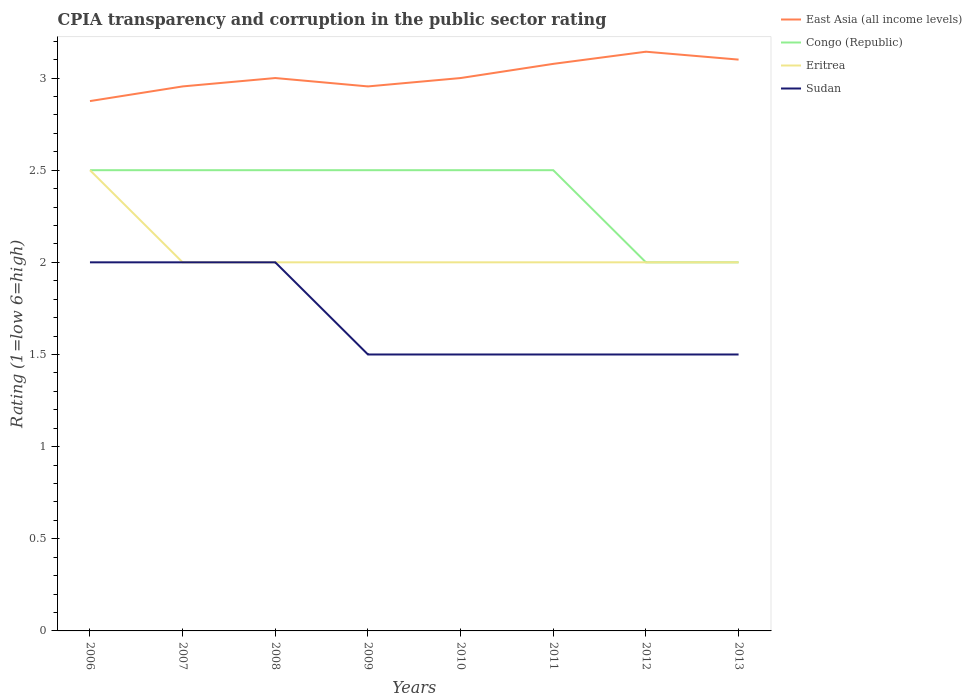Does the line corresponding to East Asia (all income levels) intersect with the line corresponding to Eritrea?
Your response must be concise. No. Across all years, what is the maximum CPIA rating in Congo (Republic)?
Make the answer very short. 2. What is the difference between the highest and the lowest CPIA rating in Eritrea?
Ensure brevity in your answer.  1. Is the CPIA rating in Eritrea strictly greater than the CPIA rating in Sudan over the years?
Your response must be concise. No. How many lines are there?
Your response must be concise. 4. How many years are there in the graph?
Offer a very short reply. 8. Are the values on the major ticks of Y-axis written in scientific E-notation?
Provide a succinct answer. No. Does the graph contain any zero values?
Ensure brevity in your answer.  No. Where does the legend appear in the graph?
Give a very brief answer. Top right. What is the title of the graph?
Offer a very short reply. CPIA transparency and corruption in the public sector rating. What is the label or title of the X-axis?
Provide a short and direct response. Years. What is the label or title of the Y-axis?
Your answer should be compact. Rating (1=low 6=high). What is the Rating (1=low 6=high) of East Asia (all income levels) in 2006?
Make the answer very short. 2.88. What is the Rating (1=low 6=high) of East Asia (all income levels) in 2007?
Provide a short and direct response. 2.95. What is the Rating (1=low 6=high) in Congo (Republic) in 2007?
Keep it short and to the point. 2.5. What is the Rating (1=low 6=high) in East Asia (all income levels) in 2008?
Provide a short and direct response. 3. What is the Rating (1=low 6=high) of East Asia (all income levels) in 2009?
Provide a short and direct response. 2.95. What is the Rating (1=low 6=high) of Congo (Republic) in 2009?
Your response must be concise. 2.5. What is the Rating (1=low 6=high) in Eritrea in 2009?
Make the answer very short. 2. What is the Rating (1=low 6=high) in Sudan in 2009?
Keep it short and to the point. 1.5. What is the Rating (1=low 6=high) of East Asia (all income levels) in 2010?
Ensure brevity in your answer.  3. What is the Rating (1=low 6=high) in East Asia (all income levels) in 2011?
Offer a very short reply. 3.08. What is the Rating (1=low 6=high) in Congo (Republic) in 2011?
Your answer should be very brief. 2.5. What is the Rating (1=low 6=high) in Eritrea in 2011?
Your answer should be very brief. 2. What is the Rating (1=low 6=high) in Sudan in 2011?
Provide a succinct answer. 1.5. What is the Rating (1=low 6=high) of East Asia (all income levels) in 2012?
Provide a short and direct response. 3.14. What is the Rating (1=low 6=high) of Sudan in 2012?
Offer a terse response. 1.5. What is the Rating (1=low 6=high) of East Asia (all income levels) in 2013?
Provide a short and direct response. 3.1. What is the Rating (1=low 6=high) of Eritrea in 2013?
Give a very brief answer. 2. What is the Rating (1=low 6=high) in Sudan in 2013?
Offer a very short reply. 1.5. Across all years, what is the maximum Rating (1=low 6=high) of East Asia (all income levels)?
Provide a short and direct response. 3.14. Across all years, what is the maximum Rating (1=low 6=high) of Congo (Republic)?
Make the answer very short. 2.5. Across all years, what is the maximum Rating (1=low 6=high) of Eritrea?
Give a very brief answer. 2.5. Across all years, what is the minimum Rating (1=low 6=high) in East Asia (all income levels)?
Make the answer very short. 2.88. Across all years, what is the minimum Rating (1=low 6=high) in Congo (Republic)?
Provide a succinct answer. 2. Across all years, what is the minimum Rating (1=low 6=high) of Eritrea?
Provide a short and direct response. 2. What is the total Rating (1=low 6=high) of East Asia (all income levels) in the graph?
Your response must be concise. 24.1. What is the difference between the Rating (1=low 6=high) of East Asia (all income levels) in 2006 and that in 2007?
Give a very brief answer. -0.08. What is the difference between the Rating (1=low 6=high) of Congo (Republic) in 2006 and that in 2007?
Keep it short and to the point. 0. What is the difference between the Rating (1=low 6=high) of Eritrea in 2006 and that in 2007?
Ensure brevity in your answer.  0.5. What is the difference between the Rating (1=low 6=high) of East Asia (all income levels) in 2006 and that in 2008?
Your answer should be very brief. -0.12. What is the difference between the Rating (1=low 6=high) in Eritrea in 2006 and that in 2008?
Give a very brief answer. 0.5. What is the difference between the Rating (1=low 6=high) of Sudan in 2006 and that in 2008?
Provide a short and direct response. 0. What is the difference between the Rating (1=low 6=high) in East Asia (all income levels) in 2006 and that in 2009?
Give a very brief answer. -0.08. What is the difference between the Rating (1=low 6=high) of Sudan in 2006 and that in 2009?
Keep it short and to the point. 0.5. What is the difference between the Rating (1=low 6=high) in East Asia (all income levels) in 2006 and that in 2010?
Give a very brief answer. -0.12. What is the difference between the Rating (1=low 6=high) in Congo (Republic) in 2006 and that in 2010?
Ensure brevity in your answer.  0. What is the difference between the Rating (1=low 6=high) of East Asia (all income levels) in 2006 and that in 2011?
Provide a short and direct response. -0.2. What is the difference between the Rating (1=low 6=high) of East Asia (all income levels) in 2006 and that in 2012?
Keep it short and to the point. -0.27. What is the difference between the Rating (1=low 6=high) in Eritrea in 2006 and that in 2012?
Provide a short and direct response. 0.5. What is the difference between the Rating (1=low 6=high) in Sudan in 2006 and that in 2012?
Give a very brief answer. 0.5. What is the difference between the Rating (1=low 6=high) of East Asia (all income levels) in 2006 and that in 2013?
Give a very brief answer. -0.23. What is the difference between the Rating (1=low 6=high) of East Asia (all income levels) in 2007 and that in 2008?
Ensure brevity in your answer.  -0.05. What is the difference between the Rating (1=low 6=high) of Sudan in 2007 and that in 2008?
Offer a very short reply. 0. What is the difference between the Rating (1=low 6=high) in East Asia (all income levels) in 2007 and that in 2009?
Keep it short and to the point. 0. What is the difference between the Rating (1=low 6=high) of Congo (Republic) in 2007 and that in 2009?
Your answer should be compact. 0. What is the difference between the Rating (1=low 6=high) in Sudan in 2007 and that in 2009?
Your response must be concise. 0.5. What is the difference between the Rating (1=low 6=high) of East Asia (all income levels) in 2007 and that in 2010?
Keep it short and to the point. -0.05. What is the difference between the Rating (1=low 6=high) in Congo (Republic) in 2007 and that in 2010?
Your answer should be very brief. 0. What is the difference between the Rating (1=low 6=high) in East Asia (all income levels) in 2007 and that in 2011?
Provide a succinct answer. -0.12. What is the difference between the Rating (1=low 6=high) of Congo (Republic) in 2007 and that in 2011?
Make the answer very short. 0. What is the difference between the Rating (1=low 6=high) in Sudan in 2007 and that in 2011?
Keep it short and to the point. 0.5. What is the difference between the Rating (1=low 6=high) in East Asia (all income levels) in 2007 and that in 2012?
Offer a terse response. -0.19. What is the difference between the Rating (1=low 6=high) in Congo (Republic) in 2007 and that in 2012?
Provide a short and direct response. 0.5. What is the difference between the Rating (1=low 6=high) in Eritrea in 2007 and that in 2012?
Keep it short and to the point. 0. What is the difference between the Rating (1=low 6=high) of East Asia (all income levels) in 2007 and that in 2013?
Make the answer very short. -0.15. What is the difference between the Rating (1=low 6=high) in Congo (Republic) in 2007 and that in 2013?
Provide a short and direct response. 0.5. What is the difference between the Rating (1=low 6=high) of Sudan in 2007 and that in 2013?
Provide a succinct answer. 0.5. What is the difference between the Rating (1=low 6=high) of East Asia (all income levels) in 2008 and that in 2009?
Your answer should be compact. 0.05. What is the difference between the Rating (1=low 6=high) in Sudan in 2008 and that in 2009?
Provide a succinct answer. 0.5. What is the difference between the Rating (1=low 6=high) of Congo (Republic) in 2008 and that in 2010?
Your response must be concise. 0. What is the difference between the Rating (1=low 6=high) in Eritrea in 2008 and that in 2010?
Provide a short and direct response. 0. What is the difference between the Rating (1=low 6=high) in Sudan in 2008 and that in 2010?
Keep it short and to the point. 0.5. What is the difference between the Rating (1=low 6=high) in East Asia (all income levels) in 2008 and that in 2011?
Your answer should be very brief. -0.08. What is the difference between the Rating (1=low 6=high) of Congo (Republic) in 2008 and that in 2011?
Provide a succinct answer. 0. What is the difference between the Rating (1=low 6=high) in Eritrea in 2008 and that in 2011?
Provide a short and direct response. 0. What is the difference between the Rating (1=low 6=high) in Sudan in 2008 and that in 2011?
Ensure brevity in your answer.  0.5. What is the difference between the Rating (1=low 6=high) of East Asia (all income levels) in 2008 and that in 2012?
Offer a very short reply. -0.14. What is the difference between the Rating (1=low 6=high) of Eritrea in 2008 and that in 2012?
Provide a short and direct response. 0. What is the difference between the Rating (1=low 6=high) in East Asia (all income levels) in 2009 and that in 2010?
Offer a very short reply. -0.05. What is the difference between the Rating (1=low 6=high) in Eritrea in 2009 and that in 2010?
Offer a very short reply. 0. What is the difference between the Rating (1=low 6=high) in Sudan in 2009 and that in 2010?
Keep it short and to the point. 0. What is the difference between the Rating (1=low 6=high) of East Asia (all income levels) in 2009 and that in 2011?
Ensure brevity in your answer.  -0.12. What is the difference between the Rating (1=low 6=high) in East Asia (all income levels) in 2009 and that in 2012?
Offer a very short reply. -0.19. What is the difference between the Rating (1=low 6=high) in East Asia (all income levels) in 2009 and that in 2013?
Provide a succinct answer. -0.15. What is the difference between the Rating (1=low 6=high) of East Asia (all income levels) in 2010 and that in 2011?
Make the answer very short. -0.08. What is the difference between the Rating (1=low 6=high) of Congo (Republic) in 2010 and that in 2011?
Your response must be concise. 0. What is the difference between the Rating (1=low 6=high) of East Asia (all income levels) in 2010 and that in 2012?
Keep it short and to the point. -0.14. What is the difference between the Rating (1=low 6=high) of Congo (Republic) in 2010 and that in 2012?
Provide a succinct answer. 0.5. What is the difference between the Rating (1=low 6=high) in Eritrea in 2010 and that in 2012?
Offer a terse response. 0. What is the difference between the Rating (1=low 6=high) in Congo (Republic) in 2010 and that in 2013?
Offer a very short reply. 0.5. What is the difference between the Rating (1=low 6=high) of Sudan in 2010 and that in 2013?
Your answer should be compact. 0. What is the difference between the Rating (1=low 6=high) in East Asia (all income levels) in 2011 and that in 2012?
Offer a very short reply. -0.07. What is the difference between the Rating (1=low 6=high) in East Asia (all income levels) in 2011 and that in 2013?
Your answer should be compact. -0.02. What is the difference between the Rating (1=low 6=high) of Congo (Republic) in 2011 and that in 2013?
Your answer should be compact. 0.5. What is the difference between the Rating (1=low 6=high) in East Asia (all income levels) in 2012 and that in 2013?
Give a very brief answer. 0.04. What is the difference between the Rating (1=low 6=high) of East Asia (all income levels) in 2006 and the Rating (1=low 6=high) of Congo (Republic) in 2007?
Ensure brevity in your answer.  0.38. What is the difference between the Rating (1=low 6=high) in East Asia (all income levels) in 2006 and the Rating (1=low 6=high) in Eritrea in 2007?
Offer a very short reply. 0.88. What is the difference between the Rating (1=low 6=high) of East Asia (all income levels) in 2006 and the Rating (1=low 6=high) of Sudan in 2007?
Offer a terse response. 0.88. What is the difference between the Rating (1=low 6=high) in Congo (Republic) in 2006 and the Rating (1=low 6=high) in Eritrea in 2007?
Offer a terse response. 0.5. What is the difference between the Rating (1=low 6=high) of Eritrea in 2006 and the Rating (1=low 6=high) of Sudan in 2007?
Your answer should be very brief. 0.5. What is the difference between the Rating (1=low 6=high) in East Asia (all income levels) in 2006 and the Rating (1=low 6=high) in Congo (Republic) in 2008?
Provide a short and direct response. 0.38. What is the difference between the Rating (1=low 6=high) in Congo (Republic) in 2006 and the Rating (1=low 6=high) in Eritrea in 2008?
Ensure brevity in your answer.  0.5. What is the difference between the Rating (1=low 6=high) of Eritrea in 2006 and the Rating (1=low 6=high) of Sudan in 2008?
Keep it short and to the point. 0.5. What is the difference between the Rating (1=low 6=high) in East Asia (all income levels) in 2006 and the Rating (1=low 6=high) in Congo (Republic) in 2009?
Your answer should be very brief. 0.38. What is the difference between the Rating (1=low 6=high) of East Asia (all income levels) in 2006 and the Rating (1=low 6=high) of Sudan in 2009?
Your answer should be very brief. 1.38. What is the difference between the Rating (1=low 6=high) of Congo (Republic) in 2006 and the Rating (1=low 6=high) of Eritrea in 2009?
Ensure brevity in your answer.  0.5. What is the difference between the Rating (1=low 6=high) of East Asia (all income levels) in 2006 and the Rating (1=low 6=high) of Eritrea in 2010?
Give a very brief answer. 0.88. What is the difference between the Rating (1=low 6=high) of East Asia (all income levels) in 2006 and the Rating (1=low 6=high) of Sudan in 2010?
Keep it short and to the point. 1.38. What is the difference between the Rating (1=low 6=high) of Congo (Republic) in 2006 and the Rating (1=low 6=high) of Eritrea in 2010?
Offer a terse response. 0.5. What is the difference between the Rating (1=low 6=high) of Congo (Republic) in 2006 and the Rating (1=low 6=high) of Sudan in 2010?
Provide a short and direct response. 1. What is the difference between the Rating (1=low 6=high) in East Asia (all income levels) in 2006 and the Rating (1=low 6=high) in Sudan in 2011?
Provide a succinct answer. 1.38. What is the difference between the Rating (1=low 6=high) of Congo (Republic) in 2006 and the Rating (1=low 6=high) of Sudan in 2011?
Your response must be concise. 1. What is the difference between the Rating (1=low 6=high) in East Asia (all income levels) in 2006 and the Rating (1=low 6=high) in Eritrea in 2012?
Your answer should be compact. 0.88. What is the difference between the Rating (1=low 6=high) of East Asia (all income levels) in 2006 and the Rating (1=low 6=high) of Sudan in 2012?
Provide a short and direct response. 1.38. What is the difference between the Rating (1=low 6=high) in Congo (Republic) in 2006 and the Rating (1=low 6=high) in Eritrea in 2012?
Your answer should be very brief. 0.5. What is the difference between the Rating (1=low 6=high) in Congo (Republic) in 2006 and the Rating (1=low 6=high) in Sudan in 2012?
Make the answer very short. 1. What is the difference between the Rating (1=low 6=high) of Eritrea in 2006 and the Rating (1=low 6=high) of Sudan in 2012?
Offer a very short reply. 1. What is the difference between the Rating (1=low 6=high) of East Asia (all income levels) in 2006 and the Rating (1=low 6=high) of Eritrea in 2013?
Your answer should be compact. 0.88. What is the difference between the Rating (1=low 6=high) in East Asia (all income levels) in 2006 and the Rating (1=low 6=high) in Sudan in 2013?
Provide a short and direct response. 1.38. What is the difference between the Rating (1=low 6=high) of Congo (Republic) in 2006 and the Rating (1=low 6=high) of Eritrea in 2013?
Your response must be concise. 0.5. What is the difference between the Rating (1=low 6=high) of East Asia (all income levels) in 2007 and the Rating (1=low 6=high) of Congo (Republic) in 2008?
Give a very brief answer. 0.45. What is the difference between the Rating (1=low 6=high) of East Asia (all income levels) in 2007 and the Rating (1=low 6=high) of Eritrea in 2008?
Provide a short and direct response. 0.95. What is the difference between the Rating (1=low 6=high) in East Asia (all income levels) in 2007 and the Rating (1=low 6=high) in Sudan in 2008?
Give a very brief answer. 0.95. What is the difference between the Rating (1=low 6=high) in Congo (Republic) in 2007 and the Rating (1=low 6=high) in Eritrea in 2008?
Make the answer very short. 0.5. What is the difference between the Rating (1=low 6=high) of Congo (Republic) in 2007 and the Rating (1=low 6=high) of Sudan in 2008?
Provide a succinct answer. 0.5. What is the difference between the Rating (1=low 6=high) in East Asia (all income levels) in 2007 and the Rating (1=low 6=high) in Congo (Republic) in 2009?
Your answer should be compact. 0.45. What is the difference between the Rating (1=low 6=high) of East Asia (all income levels) in 2007 and the Rating (1=low 6=high) of Eritrea in 2009?
Offer a terse response. 0.95. What is the difference between the Rating (1=low 6=high) of East Asia (all income levels) in 2007 and the Rating (1=low 6=high) of Sudan in 2009?
Ensure brevity in your answer.  1.45. What is the difference between the Rating (1=low 6=high) in Eritrea in 2007 and the Rating (1=low 6=high) in Sudan in 2009?
Provide a short and direct response. 0.5. What is the difference between the Rating (1=low 6=high) in East Asia (all income levels) in 2007 and the Rating (1=low 6=high) in Congo (Republic) in 2010?
Your answer should be compact. 0.45. What is the difference between the Rating (1=low 6=high) of East Asia (all income levels) in 2007 and the Rating (1=low 6=high) of Eritrea in 2010?
Give a very brief answer. 0.95. What is the difference between the Rating (1=low 6=high) of East Asia (all income levels) in 2007 and the Rating (1=low 6=high) of Sudan in 2010?
Keep it short and to the point. 1.45. What is the difference between the Rating (1=low 6=high) in Congo (Republic) in 2007 and the Rating (1=low 6=high) in Eritrea in 2010?
Offer a terse response. 0.5. What is the difference between the Rating (1=low 6=high) in East Asia (all income levels) in 2007 and the Rating (1=low 6=high) in Congo (Republic) in 2011?
Your response must be concise. 0.45. What is the difference between the Rating (1=low 6=high) of East Asia (all income levels) in 2007 and the Rating (1=low 6=high) of Eritrea in 2011?
Keep it short and to the point. 0.95. What is the difference between the Rating (1=low 6=high) of East Asia (all income levels) in 2007 and the Rating (1=low 6=high) of Sudan in 2011?
Give a very brief answer. 1.45. What is the difference between the Rating (1=low 6=high) in Congo (Republic) in 2007 and the Rating (1=low 6=high) in Eritrea in 2011?
Your answer should be very brief. 0.5. What is the difference between the Rating (1=low 6=high) of East Asia (all income levels) in 2007 and the Rating (1=low 6=high) of Congo (Republic) in 2012?
Your answer should be very brief. 0.95. What is the difference between the Rating (1=low 6=high) of East Asia (all income levels) in 2007 and the Rating (1=low 6=high) of Eritrea in 2012?
Keep it short and to the point. 0.95. What is the difference between the Rating (1=low 6=high) in East Asia (all income levels) in 2007 and the Rating (1=low 6=high) in Sudan in 2012?
Your answer should be compact. 1.45. What is the difference between the Rating (1=low 6=high) in Congo (Republic) in 2007 and the Rating (1=low 6=high) in Eritrea in 2012?
Ensure brevity in your answer.  0.5. What is the difference between the Rating (1=low 6=high) of Congo (Republic) in 2007 and the Rating (1=low 6=high) of Sudan in 2012?
Your answer should be very brief. 1. What is the difference between the Rating (1=low 6=high) in Eritrea in 2007 and the Rating (1=low 6=high) in Sudan in 2012?
Offer a terse response. 0.5. What is the difference between the Rating (1=low 6=high) in East Asia (all income levels) in 2007 and the Rating (1=low 6=high) in Congo (Republic) in 2013?
Offer a terse response. 0.95. What is the difference between the Rating (1=low 6=high) of East Asia (all income levels) in 2007 and the Rating (1=low 6=high) of Eritrea in 2013?
Provide a short and direct response. 0.95. What is the difference between the Rating (1=low 6=high) in East Asia (all income levels) in 2007 and the Rating (1=low 6=high) in Sudan in 2013?
Your answer should be compact. 1.45. What is the difference between the Rating (1=low 6=high) of Eritrea in 2007 and the Rating (1=low 6=high) of Sudan in 2013?
Offer a terse response. 0.5. What is the difference between the Rating (1=low 6=high) of East Asia (all income levels) in 2008 and the Rating (1=low 6=high) of Eritrea in 2009?
Offer a terse response. 1. What is the difference between the Rating (1=low 6=high) in East Asia (all income levels) in 2008 and the Rating (1=low 6=high) in Sudan in 2009?
Provide a short and direct response. 1.5. What is the difference between the Rating (1=low 6=high) in East Asia (all income levels) in 2008 and the Rating (1=low 6=high) in Eritrea in 2010?
Your response must be concise. 1. What is the difference between the Rating (1=low 6=high) in Congo (Republic) in 2008 and the Rating (1=low 6=high) in Sudan in 2010?
Offer a terse response. 1. What is the difference between the Rating (1=low 6=high) of East Asia (all income levels) in 2008 and the Rating (1=low 6=high) of Congo (Republic) in 2011?
Offer a terse response. 0.5. What is the difference between the Rating (1=low 6=high) in East Asia (all income levels) in 2008 and the Rating (1=low 6=high) in Eritrea in 2011?
Offer a very short reply. 1. What is the difference between the Rating (1=low 6=high) in East Asia (all income levels) in 2008 and the Rating (1=low 6=high) in Sudan in 2011?
Make the answer very short. 1.5. What is the difference between the Rating (1=low 6=high) of Congo (Republic) in 2008 and the Rating (1=low 6=high) of Eritrea in 2011?
Make the answer very short. 0.5. What is the difference between the Rating (1=low 6=high) in Congo (Republic) in 2008 and the Rating (1=low 6=high) in Sudan in 2011?
Make the answer very short. 1. What is the difference between the Rating (1=low 6=high) of Eritrea in 2008 and the Rating (1=low 6=high) of Sudan in 2011?
Your response must be concise. 0.5. What is the difference between the Rating (1=low 6=high) of Congo (Republic) in 2008 and the Rating (1=low 6=high) of Eritrea in 2012?
Make the answer very short. 0.5. What is the difference between the Rating (1=low 6=high) of Eritrea in 2008 and the Rating (1=low 6=high) of Sudan in 2012?
Your answer should be compact. 0.5. What is the difference between the Rating (1=low 6=high) in East Asia (all income levels) in 2009 and the Rating (1=low 6=high) in Congo (Republic) in 2010?
Your answer should be compact. 0.45. What is the difference between the Rating (1=low 6=high) in East Asia (all income levels) in 2009 and the Rating (1=low 6=high) in Eritrea in 2010?
Offer a terse response. 0.95. What is the difference between the Rating (1=low 6=high) of East Asia (all income levels) in 2009 and the Rating (1=low 6=high) of Sudan in 2010?
Give a very brief answer. 1.45. What is the difference between the Rating (1=low 6=high) of East Asia (all income levels) in 2009 and the Rating (1=low 6=high) of Congo (Republic) in 2011?
Your response must be concise. 0.45. What is the difference between the Rating (1=low 6=high) of East Asia (all income levels) in 2009 and the Rating (1=low 6=high) of Eritrea in 2011?
Give a very brief answer. 0.95. What is the difference between the Rating (1=low 6=high) in East Asia (all income levels) in 2009 and the Rating (1=low 6=high) in Sudan in 2011?
Make the answer very short. 1.45. What is the difference between the Rating (1=low 6=high) of Congo (Republic) in 2009 and the Rating (1=low 6=high) of Sudan in 2011?
Provide a succinct answer. 1. What is the difference between the Rating (1=low 6=high) in Eritrea in 2009 and the Rating (1=low 6=high) in Sudan in 2011?
Offer a very short reply. 0.5. What is the difference between the Rating (1=low 6=high) in East Asia (all income levels) in 2009 and the Rating (1=low 6=high) in Congo (Republic) in 2012?
Give a very brief answer. 0.95. What is the difference between the Rating (1=low 6=high) of East Asia (all income levels) in 2009 and the Rating (1=low 6=high) of Eritrea in 2012?
Keep it short and to the point. 0.95. What is the difference between the Rating (1=low 6=high) of East Asia (all income levels) in 2009 and the Rating (1=low 6=high) of Sudan in 2012?
Your response must be concise. 1.45. What is the difference between the Rating (1=low 6=high) of East Asia (all income levels) in 2009 and the Rating (1=low 6=high) of Congo (Republic) in 2013?
Provide a succinct answer. 0.95. What is the difference between the Rating (1=low 6=high) of East Asia (all income levels) in 2009 and the Rating (1=low 6=high) of Eritrea in 2013?
Provide a short and direct response. 0.95. What is the difference between the Rating (1=low 6=high) of East Asia (all income levels) in 2009 and the Rating (1=low 6=high) of Sudan in 2013?
Your answer should be very brief. 1.45. What is the difference between the Rating (1=low 6=high) of Congo (Republic) in 2009 and the Rating (1=low 6=high) of Eritrea in 2013?
Offer a very short reply. 0.5. What is the difference between the Rating (1=low 6=high) of Congo (Republic) in 2009 and the Rating (1=low 6=high) of Sudan in 2013?
Your answer should be compact. 1. What is the difference between the Rating (1=low 6=high) in Eritrea in 2009 and the Rating (1=low 6=high) in Sudan in 2013?
Your response must be concise. 0.5. What is the difference between the Rating (1=low 6=high) of East Asia (all income levels) in 2010 and the Rating (1=low 6=high) of Congo (Republic) in 2011?
Provide a succinct answer. 0.5. What is the difference between the Rating (1=low 6=high) in Congo (Republic) in 2010 and the Rating (1=low 6=high) in Eritrea in 2011?
Give a very brief answer. 0.5. What is the difference between the Rating (1=low 6=high) in Congo (Republic) in 2010 and the Rating (1=low 6=high) in Sudan in 2011?
Provide a succinct answer. 1. What is the difference between the Rating (1=low 6=high) in Eritrea in 2010 and the Rating (1=low 6=high) in Sudan in 2011?
Give a very brief answer. 0.5. What is the difference between the Rating (1=low 6=high) of East Asia (all income levels) in 2010 and the Rating (1=low 6=high) of Congo (Republic) in 2012?
Offer a very short reply. 1. What is the difference between the Rating (1=low 6=high) in East Asia (all income levels) in 2010 and the Rating (1=low 6=high) in Sudan in 2012?
Your answer should be very brief. 1.5. What is the difference between the Rating (1=low 6=high) in Eritrea in 2010 and the Rating (1=low 6=high) in Sudan in 2012?
Give a very brief answer. 0.5. What is the difference between the Rating (1=low 6=high) in Congo (Republic) in 2010 and the Rating (1=low 6=high) in Eritrea in 2013?
Make the answer very short. 0.5. What is the difference between the Rating (1=low 6=high) in Congo (Republic) in 2010 and the Rating (1=low 6=high) in Sudan in 2013?
Your answer should be compact. 1. What is the difference between the Rating (1=low 6=high) of East Asia (all income levels) in 2011 and the Rating (1=low 6=high) of Sudan in 2012?
Ensure brevity in your answer.  1.58. What is the difference between the Rating (1=low 6=high) in Congo (Republic) in 2011 and the Rating (1=low 6=high) in Eritrea in 2012?
Offer a very short reply. 0.5. What is the difference between the Rating (1=low 6=high) in East Asia (all income levels) in 2011 and the Rating (1=low 6=high) in Congo (Republic) in 2013?
Your answer should be compact. 1.08. What is the difference between the Rating (1=low 6=high) of East Asia (all income levels) in 2011 and the Rating (1=low 6=high) of Sudan in 2013?
Ensure brevity in your answer.  1.58. What is the difference between the Rating (1=low 6=high) in Congo (Republic) in 2011 and the Rating (1=low 6=high) in Sudan in 2013?
Provide a short and direct response. 1. What is the difference between the Rating (1=low 6=high) of East Asia (all income levels) in 2012 and the Rating (1=low 6=high) of Congo (Republic) in 2013?
Provide a short and direct response. 1.14. What is the difference between the Rating (1=low 6=high) of East Asia (all income levels) in 2012 and the Rating (1=low 6=high) of Sudan in 2013?
Your answer should be very brief. 1.64. What is the difference between the Rating (1=low 6=high) of Eritrea in 2012 and the Rating (1=low 6=high) of Sudan in 2013?
Keep it short and to the point. 0.5. What is the average Rating (1=low 6=high) in East Asia (all income levels) per year?
Your answer should be very brief. 3.01. What is the average Rating (1=low 6=high) in Congo (Republic) per year?
Offer a very short reply. 2.38. What is the average Rating (1=low 6=high) of Eritrea per year?
Ensure brevity in your answer.  2.06. What is the average Rating (1=low 6=high) in Sudan per year?
Keep it short and to the point. 1.69. In the year 2006, what is the difference between the Rating (1=low 6=high) in East Asia (all income levels) and Rating (1=low 6=high) in Congo (Republic)?
Your answer should be compact. 0.38. In the year 2006, what is the difference between the Rating (1=low 6=high) of East Asia (all income levels) and Rating (1=low 6=high) of Sudan?
Offer a terse response. 0.88. In the year 2006, what is the difference between the Rating (1=low 6=high) in Congo (Republic) and Rating (1=low 6=high) in Eritrea?
Provide a succinct answer. 0. In the year 2007, what is the difference between the Rating (1=low 6=high) in East Asia (all income levels) and Rating (1=low 6=high) in Congo (Republic)?
Ensure brevity in your answer.  0.45. In the year 2007, what is the difference between the Rating (1=low 6=high) of East Asia (all income levels) and Rating (1=low 6=high) of Eritrea?
Your response must be concise. 0.95. In the year 2007, what is the difference between the Rating (1=low 6=high) of East Asia (all income levels) and Rating (1=low 6=high) of Sudan?
Give a very brief answer. 0.95. In the year 2007, what is the difference between the Rating (1=low 6=high) in Congo (Republic) and Rating (1=low 6=high) in Eritrea?
Your response must be concise. 0.5. In the year 2007, what is the difference between the Rating (1=low 6=high) of Eritrea and Rating (1=low 6=high) of Sudan?
Your response must be concise. 0. In the year 2009, what is the difference between the Rating (1=low 6=high) of East Asia (all income levels) and Rating (1=low 6=high) of Congo (Republic)?
Your answer should be compact. 0.45. In the year 2009, what is the difference between the Rating (1=low 6=high) in East Asia (all income levels) and Rating (1=low 6=high) in Eritrea?
Your answer should be compact. 0.95. In the year 2009, what is the difference between the Rating (1=low 6=high) of East Asia (all income levels) and Rating (1=low 6=high) of Sudan?
Provide a short and direct response. 1.45. In the year 2009, what is the difference between the Rating (1=low 6=high) of Congo (Republic) and Rating (1=low 6=high) of Eritrea?
Your response must be concise. 0.5. In the year 2009, what is the difference between the Rating (1=low 6=high) of Congo (Republic) and Rating (1=low 6=high) of Sudan?
Offer a terse response. 1. In the year 2010, what is the difference between the Rating (1=low 6=high) of East Asia (all income levels) and Rating (1=low 6=high) of Congo (Republic)?
Your answer should be very brief. 0.5. In the year 2010, what is the difference between the Rating (1=low 6=high) of East Asia (all income levels) and Rating (1=low 6=high) of Sudan?
Provide a succinct answer. 1.5. In the year 2011, what is the difference between the Rating (1=low 6=high) of East Asia (all income levels) and Rating (1=low 6=high) of Congo (Republic)?
Make the answer very short. 0.58. In the year 2011, what is the difference between the Rating (1=low 6=high) of East Asia (all income levels) and Rating (1=low 6=high) of Sudan?
Provide a short and direct response. 1.58. In the year 2011, what is the difference between the Rating (1=low 6=high) of Congo (Republic) and Rating (1=low 6=high) of Sudan?
Provide a succinct answer. 1. In the year 2011, what is the difference between the Rating (1=low 6=high) of Eritrea and Rating (1=low 6=high) of Sudan?
Your answer should be very brief. 0.5. In the year 2012, what is the difference between the Rating (1=low 6=high) in East Asia (all income levels) and Rating (1=low 6=high) in Congo (Republic)?
Provide a short and direct response. 1.14. In the year 2012, what is the difference between the Rating (1=low 6=high) in East Asia (all income levels) and Rating (1=low 6=high) in Sudan?
Your response must be concise. 1.64. In the year 2012, what is the difference between the Rating (1=low 6=high) in Congo (Republic) and Rating (1=low 6=high) in Eritrea?
Keep it short and to the point. 0. In the year 2012, what is the difference between the Rating (1=low 6=high) of Eritrea and Rating (1=low 6=high) of Sudan?
Offer a terse response. 0.5. In the year 2013, what is the difference between the Rating (1=low 6=high) in East Asia (all income levels) and Rating (1=low 6=high) in Congo (Republic)?
Give a very brief answer. 1.1. In the year 2013, what is the difference between the Rating (1=low 6=high) of Congo (Republic) and Rating (1=low 6=high) of Eritrea?
Offer a very short reply. 0. In the year 2013, what is the difference between the Rating (1=low 6=high) in Eritrea and Rating (1=low 6=high) in Sudan?
Offer a terse response. 0.5. What is the ratio of the Rating (1=low 6=high) of East Asia (all income levels) in 2006 to that in 2007?
Offer a terse response. 0.97. What is the ratio of the Rating (1=low 6=high) of Congo (Republic) in 2006 to that in 2007?
Provide a short and direct response. 1. What is the ratio of the Rating (1=low 6=high) in East Asia (all income levels) in 2006 to that in 2008?
Offer a very short reply. 0.96. What is the ratio of the Rating (1=low 6=high) of Congo (Republic) in 2006 to that in 2008?
Offer a terse response. 1. What is the ratio of the Rating (1=low 6=high) in Eritrea in 2006 to that in 2008?
Keep it short and to the point. 1.25. What is the ratio of the Rating (1=low 6=high) in Sudan in 2006 to that in 2008?
Offer a terse response. 1. What is the ratio of the Rating (1=low 6=high) of East Asia (all income levels) in 2006 to that in 2009?
Your response must be concise. 0.97. What is the ratio of the Rating (1=low 6=high) in Congo (Republic) in 2006 to that in 2009?
Your answer should be compact. 1. What is the ratio of the Rating (1=low 6=high) in Eritrea in 2006 to that in 2009?
Provide a short and direct response. 1.25. What is the ratio of the Rating (1=low 6=high) in East Asia (all income levels) in 2006 to that in 2010?
Your answer should be compact. 0.96. What is the ratio of the Rating (1=low 6=high) of Eritrea in 2006 to that in 2010?
Your answer should be compact. 1.25. What is the ratio of the Rating (1=low 6=high) of East Asia (all income levels) in 2006 to that in 2011?
Provide a succinct answer. 0.93. What is the ratio of the Rating (1=low 6=high) in Eritrea in 2006 to that in 2011?
Provide a succinct answer. 1.25. What is the ratio of the Rating (1=low 6=high) in East Asia (all income levels) in 2006 to that in 2012?
Provide a succinct answer. 0.91. What is the ratio of the Rating (1=low 6=high) of Congo (Republic) in 2006 to that in 2012?
Ensure brevity in your answer.  1.25. What is the ratio of the Rating (1=low 6=high) in East Asia (all income levels) in 2006 to that in 2013?
Ensure brevity in your answer.  0.93. What is the ratio of the Rating (1=low 6=high) in Eritrea in 2007 to that in 2008?
Your response must be concise. 1. What is the ratio of the Rating (1=low 6=high) in Congo (Republic) in 2007 to that in 2009?
Provide a succinct answer. 1. What is the ratio of the Rating (1=low 6=high) of East Asia (all income levels) in 2007 to that in 2010?
Your answer should be compact. 0.98. What is the ratio of the Rating (1=low 6=high) of Congo (Republic) in 2007 to that in 2010?
Offer a very short reply. 1. What is the ratio of the Rating (1=low 6=high) of Sudan in 2007 to that in 2010?
Your response must be concise. 1.33. What is the ratio of the Rating (1=low 6=high) of East Asia (all income levels) in 2007 to that in 2011?
Provide a succinct answer. 0.96. What is the ratio of the Rating (1=low 6=high) in Congo (Republic) in 2007 to that in 2011?
Make the answer very short. 1. What is the ratio of the Rating (1=low 6=high) of Eritrea in 2007 to that in 2011?
Offer a terse response. 1. What is the ratio of the Rating (1=low 6=high) in East Asia (all income levels) in 2007 to that in 2012?
Make the answer very short. 0.94. What is the ratio of the Rating (1=low 6=high) of Eritrea in 2007 to that in 2012?
Your answer should be very brief. 1. What is the ratio of the Rating (1=low 6=high) of East Asia (all income levels) in 2007 to that in 2013?
Give a very brief answer. 0.95. What is the ratio of the Rating (1=low 6=high) of Eritrea in 2007 to that in 2013?
Offer a terse response. 1. What is the ratio of the Rating (1=low 6=high) of East Asia (all income levels) in 2008 to that in 2009?
Provide a short and direct response. 1.02. What is the ratio of the Rating (1=low 6=high) of Congo (Republic) in 2008 to that in 2009?
Make the answer very short. 1. What is the ratio of the Rating (1=low 6=high) in East Asia (all income levels) in 2008 to that in 2010?
Offer a terse response. 1. What is the ratio of the Rating (1=low 6=high) in Sudan in 2008 to that in 2010?
Make the answer very short. 1.33. What is the ratio of the Rating (1=low 6=high) in East Asia (all income levels) in 2008 to that in 2011?
Provide a succinct answer. 0.97. What is the ratio of the Rating (1=low 6=high) of Sudan in 2008 to that in 2011?
Your answer should be compact. 1.33. What is the ratio of the Rating (1=low 6=high) in East Asia (all income levels) in 2008 to that in 2012?
Provide a short and direct response. 0.95. What is the ratio of the Rating (1=low 6=high) in Congo (Republic) in 2008 to that in 2012?
Offer a terse response. 1.25. What is the ratio of the Rating (1=low 6=high) of Eritrea in 2008 to that in 2012?
Your response must be concise. 1. What is the ratio of the Rating (1=low 6=high) of Congo (Republic) in 2008 to that in 2013?
Keep it short and to the point. 1.25. What is the ratio of the Rating (1=low 6=high) of Sudan in 2009 to that in 2010?
Offer a terse response. 1. What is the ratio of the Rating (1=low 6=high) in East Asia (all income levels) in 2009 to that in 2011?
Keep it short and to the point. 0.96. What is the ratio of the Rating (1=low 6=high) in East Asia (all income levels) in 2009 to that in 2012?
Provide a short and direct response. 0.94. What is the ratio of the Rating (1=low 6=high) of Congo (Republic) in 2009 to that in 2012?
Offer a very short reply. 1.25. What is the ratio of the Rating (1=low 6=high) in Sudan in 2009 to that in 2012?
Provide a succinct answer. 1. What is the ratio of the Rating (1=low 6=high) of East Asia (all income levels) in 2009 to that in 2013?
Keep it short and to the point. 0.95. What is the ratio of the Rating (1=low 6=high) in Congo (Republic) in 2009 to that in 2013?
Your answer should be very brief. 1.25. What is the ratio of the Rating (1=low 6=high) in East Asia (all income levels) in 2010 to that in 2011?
Ensure brevity in your answer.  0.97. What is the ratio of the Rating (1=low 6=high) of Eritrea in 2010 to that in 2011?
Give a very brief answer. 1. What is the ratio of the Rating (1=low 6=high) in Sudan in 2010 to that in 2011?
Your answer should be compact. 1. What is the ratio of the Rating (1=low 6=high) of East Asia (all income levels) in 2010 to that in 2012?
Make the answer very short. 0.95. What is the ratio of the Rating (1=low 6=high) of Congo (Republic) in 2010 to that in 2012?
Your response must be concise. 1.25. What is the ratio of the Rating (1=low 6=high) of Sudan in 2010 to that in 2012?
Give a very brief answer. 1. What is the ratio of the Rating (1=low 6=high) in Eritrea in 2010 to that in 2013?
Offer a terse response. 1. What is the ratio of the Rating (1=low 6=high) of Sudan in 2010 to that in 2013?
Your response must be concise. 1. What is the ratio of the Rating (1=low 6=high) of East Asia (all income levels) in 2011 to that in 2012?
Your answer should be very brief. 0.98. What is the ratio of the Rating (1=low 6=high) of Congo (Republic) in 2011 to that in 2012?
Your answer should be compact. 1.25. What is the ratio of the Rating (1=low 6=high) in Eritrea in 2011 to that in 2012?
Make the answer very short. 1. What is the ratio of the Rating (1=low 6=high) of Sudan in 2011 to that in 2012?
Offer a very short reply. 1. What is the ratio of the Rating (1=low 6=high) of Congo (Republic) in 2011 to that in 2013?
Your response must be concise. 1.25. What is the ratio of the Rating (1=low 6=high) in Eritrea in 2011 to that in 2013?
Make the answer very short. 1. What is the ratio of the Rating (1=low 6=high) of Sudan in 2011 to that in 2013?
Offer a terse response. 1. What is the ratio of the Rating (1=low 6=high) in East Asia (all income levels) in 2012 to that in 2013?
Your answer should be compact. 1.01. What is the ratio of the Rating (1=low 6=high) in Eritrea in 2012 to that in 2013?
Ensure brevity in your answer.  1. What is the difference between the highest and the second highest Rating (1=low 6=high) in East Asia (all income levels)?
Ensure brevity in your answer.  0.04. What is the difference between the highest and the second highest Rating (1=low 6=high) in Eritrea?
Provide a succinct answer. 0.5. What is the difference between the highest and the lowest Rating (1=low 6=high) of East Asia (all income levels)?
Give a very brief answer. 0.27. 